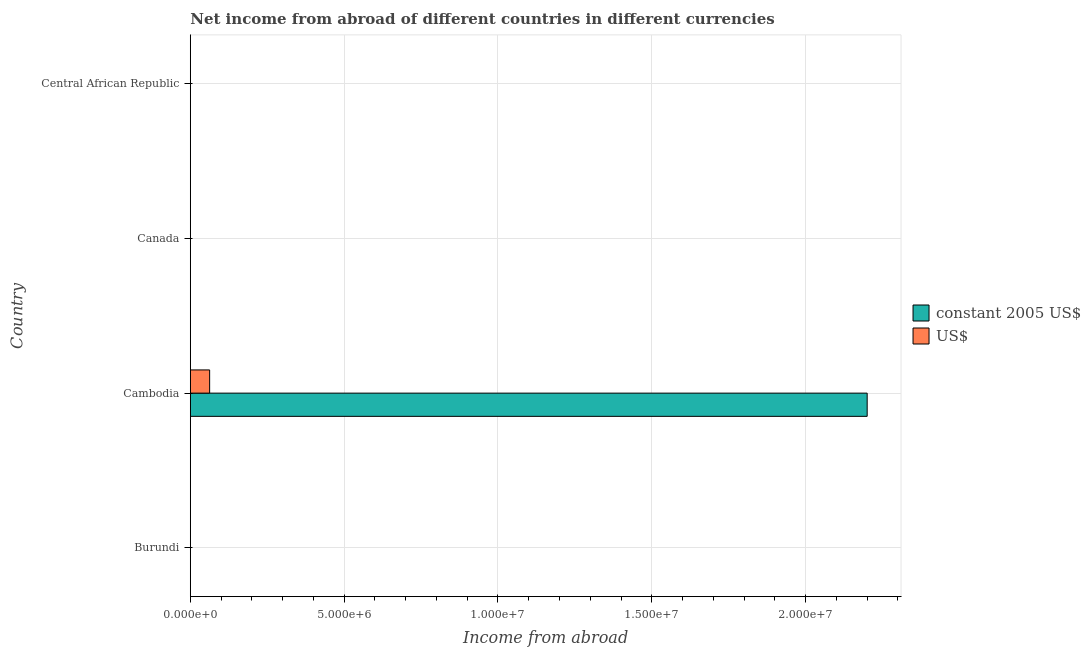Are the number of bars per tick equal to the number of legend labels?
Offer a very short reply. No. How many bars are there on the 4th tick from the top?
Provide a short and direct response. 0. How many bars are there on the 1st tick from the bottom?
Your answer should be very brief. 0. What is the label of the 1st group of bars from the top?
Make the answer very short. Central African Republic. What is the income from abroad in us$ in Canada?
Provide a succinct answer. 0. Across all countries, what is the maximum income from abroad in constant 2005 us$?
Provide a succinct answer. 2.20e+07. Across all countries, what is the minimum income from abroad in us$?
Give a very brief answer. 0. In which country was the income from abroad in constant 2005 us$ maximum?
Keep it short and to the point. Cambodia. What is the total income from abroad in constant 2005 us$ in the graph?
Provide a short and direct response. 2.20e+07. What is the difference between the income from abroad in constant 2005 us$ in Burundi and the income from abroad in us$ in Cambodia?
Provide a short and direct response. -6.29e+05. What is the average income from abroad in constant 2005 us$ per country?
Your answer should be compact. 5.50e+06. What is the difference between the income from abroad in us$ and income from abroad in constant 2005 us$ in Cambodia?
Make the answer very short. -2.14e+07. What is the difference between the highest and the lowest income from abroad in us$?
Your answer should be compact. 6.29e+05. How many countries are there in the graph?
Make the answer very short. 4. Does the graph contain grids?
Offer a terse response. Yes. Where does the legend appear in the graph?
Ensure brevity in your answer.  Center right. How many legend labels are there?
Your answer should be very brief. 2. What is the title of the graph?
Ensure brevity in your answer.  Net income from abroad of different countries in different currencies. Does "Forest land" appear as one of the legend labels in the graph?
Offer a very short reply. No. What is the label or title of the X-axis?
Offer a terse response. Income from abroad. What is the label or title of the Y-axis?
Ensure brevity in your answer.  Country. What is the Income from abroad in constant 2005 US$ in Burundi?
Make the answer very short. 0. What is the Income from abroad in US$ in Burundi?
Your answer should be compact. 0. What is the Income from abroad in constant 2005 US$ in Cambodia?
Keep it short and to the point. 2.20e+07. What is the Income from abroad of US$ in Cambodia?
Your response must be concise. 6.29e+05. What is the Income from abroad in constant 2005 US$ in Canada?
Offer a terse response. 0. Across all countries, what is the maximum Income from abroad of constant 2005 US$?
Make the answer very short. 2.20e+07. Across all countries, what is the maximum Income from abroad in US$?
Keep it short and to the point. 6.29e+05. Across all countries, what is the minimum Income from abroad of constant 2005 US$?
Your answer should be compact. 0. Across all countries, what is the minimum Income from abroad in US$?
Your response must be concise. 0. What is the total Income from abroad in constant 2005 US$ in the graph?
Your answer should be compact. 2.20e+07. What is the total Income from abroad in US$ in the graph?
Provide a short and direct response. 6.29e+05. What is the average Income from abroad of constant 2005 US$ per country?
Your answer should be very brief. 5.50e+06. What is the average Income from abroad of US$ per country?
Your answer should be compact. 1.57e+05. What is the difference between the Income from abroad of constant 2005 US$ and Income from abroad of US$ in Cambodia?
Ensure brevity in your answer.  2.14e+07. What is the difference between the highest and the lowest Income from abroad of constant 2005 US$?
Your answer should be compact. 2.20e+07. What is the difference between the highest and the lowest Income from abroad in US$?
Give a very brief answer. 6.29e+05. 